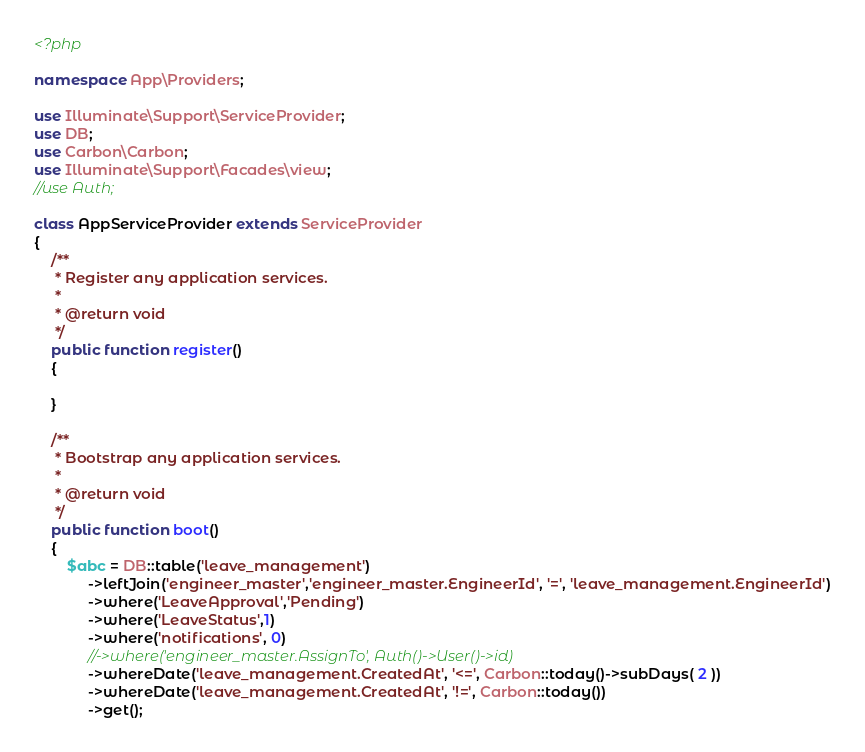Convert code to text. <code><loc_0><loc_0><loc_500><loc_500><_PHP_><?php

namespace App\Providers;

use Illuminate\Support\ServiceProvider;
use DB;
use Carbon\Carbon;
use Illuminate\Support\Facades\view;
//use Auth;

class AppServiceProvider extends ServiceProvider
{
    /**
     * Register any application services.
     *
     * @return void
     */
    public function register()
    {
        
    }

    /**
     * Bootstrap any application services.
     *
     * @return void
     */
    public function boot()
    {
        $abc = DB::table('leave_management')
             ->leftJoin('engineer_master','engineer_master.EngineerId', '=', 'leave_management.EngineerId')
             ->where('LeaveApproval','Pending')
             ->where('LeaveStatus',1)
             ->where('notifications', 0)
             //->where('engineer_master.AssignTo', Auth()->User()->id)
             ->whereDate('leave_management.CreatedAt', '<=', Carbon::today()->subDays( 2 ))
             ->whereDate('leave_management.CreatedAt', '!=', Carbon::today())
             ->get();</code> 